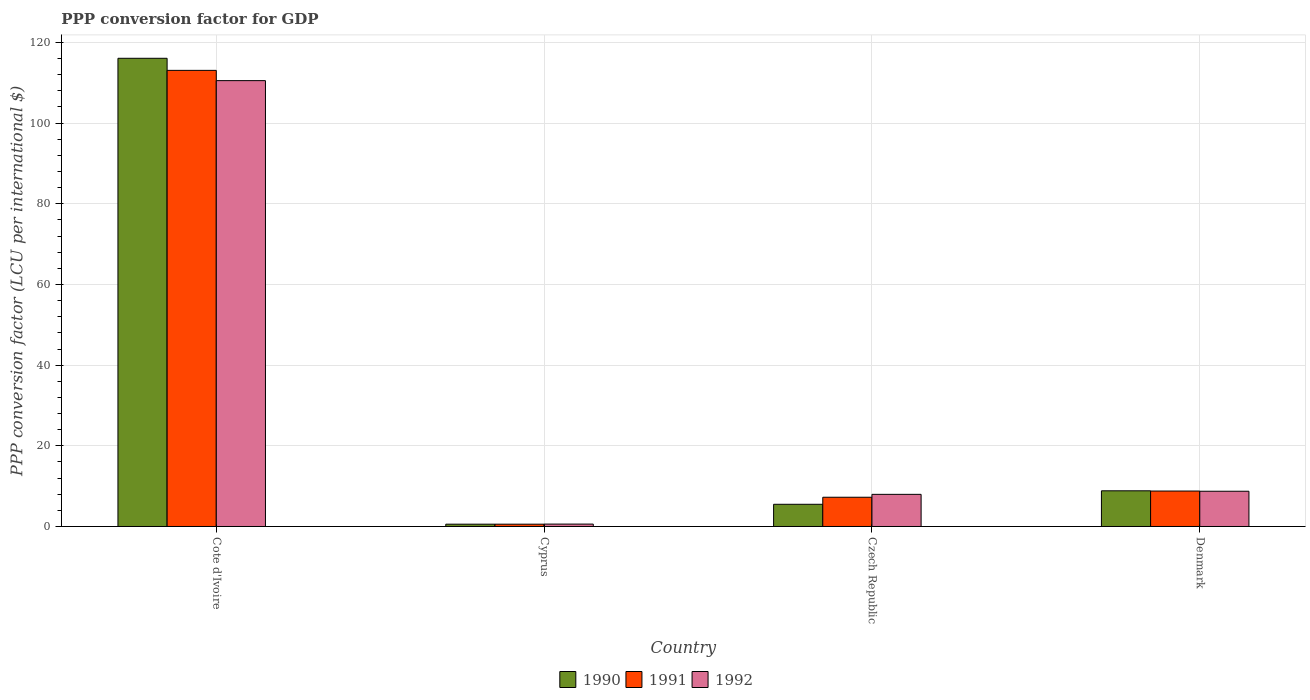How many different coloured bars are there?
Keep it short and to the point. 3. Are the number of bars per tick equal to the number of legend labels?
Your answer should be very brief. Yes. Are the number of bars on each tick of the X-axis equal?
Keep it short and to the point. Yes. What is the label of the 3rd group of bars from the left?
Ensure brevity in your answer.  Czech Republic. What is the PPP conversion factor for GDP in 1990 in Cyprus?
Keep it short and to the point. 0.57. Across all countries, what is the maximum PPP conversion factor for GDP in 1990?
Provide a succinct answer. 116.07. Across all countries, what is the minimum PPP conversion factor for GDP in 1992?
Your answer should be compact. 0.59. In which country was the PPP conversion factor for GDP in 1991 maximum?
Keep it short and to the point. Cote d'Ivoire. In which country was the PPP conversion factor for GDP in 1992 minimum?
Ensure brevity in your answer.  Cyprus. What is the total PPP conversion factor for GDP in 1992 in the graph?
Give a very brief answer. 127.83. What is the difference between the PPP conversion factor for GDP in 1990 in Cyprus and that in Denmark?
Provide a short and direct response. -8.27. What is the difference between the PPP conversion factor for GDP in 1992 in Cyprus and the PPP conversion factor for GDP in 1990 in Cote d'Ivoire?
Your response must be concise. -115.48. What is the average PPP conversion factor for GDP in 1991 per country?
Give a very brief answer. 32.42. What is the difference between the PPP conversion factor for GDP of/in 1990 and PPP conversion factor for GDP of/in 1992 in Denmark?
Ensure brevity in your answer.  0.11. What is the ratio of the PPP conversion factor for GDP in 1992 in Cote d'Ivoire to that in Denmark?
Provide a succinct answer. 12.65. Is the difference between the PPP conversion factor for GDP in 1990 in Cote d'Ivoire and Denmark greater than the difference between the PPP conversion factor for GDP in 1992 in Cote d'Ivoire and Denmark?
Give a very brief answer. Yes. What is the difference between the highest and the second highest PPP conversion factor for GDP in 1992?
Your answer should be compact. -101.79. What is the difference between the highest and the lowest PPP conversion factor for GDP in 1990?
Your answer should be very brief. 115.5. What does the 1st bar from the right in Denmark represents?
Keep it short and to the point. 1992. Is it the case that in every country, the sum of the PPP conversion factor for GDP in 1992 and PPP conversion factor for GDP in 1990 is greater than the PPP conversion factor for GDP in 1991?
Give a very brief answer. Yes. How many bars are there?
Your answer should be compact. 12. Are all the bars in the graph horizontal?
Give a very brief answer. No. Does the graph contain grids?
Provide a succinct answer. Yes. Where does the legend appear in the graph?
Offer a very short reply. Bottom center. How many legend labels are there?
Offer a terse response. 3. How are the legend labels stacked?
Your answer should be very brief. Horizontal. What is the title of the graph?
Provide a short and direct response. PPP conversion factor for GDP. What is the label or title of the Y-axis?
Make the answer very short. PPP conversion factor (LCU per international $). What is the PPP conversion factor (LCU per international $) in 1990 in Cote d'Ivoire?
Give a very brief answer. 116.07. What is the PPP conversion factor (LCU per international $) of 1991 in Cote d'Ivoire?
Provide a succinct answer. 113.08. What is the PPP conversion factor (LCU per international $) of 1992 in Cote d'Ivoire?
Your answer should be very brief. 110.53. What is the PPP conversion factor (LCU per international $) of 1990 in Cyprus?
Your answer should be very brief. 0.57. What is the PPP conversion factor (LCU per international $) in 1991 in Cyprus?
Keep it short and to the point. 0.57. What is the PPP conversion factor (LCU per international $) of 1992 in Cyprus?
Provide a succinct answer. 0.59. What is the PPP conversion factor (LCU per international $) in 1990 in Czech Republic?
Your answer should be very brief. 5.5. What is the PPP conversion factor (LCU per international $) in 1991 in Czech Republic?
Your answer should be very brief. 7.25. What is the PPP conversion factor (LCU per international $) of 1992 in Czech Republic?
Your response must be concise. 7.97. What is the PPP conversion factor (LCU per international $) in 1990 in Denmark?
Make the answer very short. 8.84. What is the PPP conversion factor (LCU per international $) in 1991 in Denmark?
Provide a succinct answer. 8.79. What is the PPP conversion factor (LCU per international $) in 1992 in Denmark?
Your answer should be compact. 8.74. Across all countries, what is the maximum PPP conversion factor (LCU per international $) of 1990?
Keep it short and to the point. 116.07. Across all countries, what is the maximum PPP conversion factor (LCU per international $) of 1991?
Provide a short and direct response. 113.08. Across all countries, what is the maximum PPP conversion factor (LCU per international $) in 1992?
Your answer should be very brief. 110.53. Across all countries, what is the minimum PPP conversion factor (LCU per international $) in 1990?
Provide a short and direct response. 0.57. Across all countries, what is the minimum PPP conversion factor (LCU per international $) in 1991?
Your response must be concise. 0.57. Across all countries, what is the minimum PPP conversion factor (LCU per international $) of 1992?
Provide a short and direct response. 0.59. What is the total PPP conversion factor (LCU per international $) of 1990 in the graph?
Give a very brief answer. 130.99. What is the total PPP conversion factor (LCU per international $) in 1991 in the graph?
Your response must be concise. 129.69. What is the total PPP conversion factor (LCU per international $) in 1992 in the graph?
Give a very brief answer. 127.83. What is the difference between the PPP conversion factor (LCU per international $) in 1990 in Cote d'Ivoire and that in Cyprus?
Offer a very short reply. 115.5. What is the difference between the PPP conversion factor (LCU per international $) in 1991 in Cote d'Ivoire and that in Cyprus?
Offer a very short reply. 112.5. What is the difference between the PPP conversion factor (LCU per international $) in 1992 in Cote d'Ivoire and that in Cyprus?
Your response must be concise. 109.94. What is the difference between the PPP conversion factor (LCU per international $) of 1990 in Cote d'Ivoire and that in Czech Republic?
Provide a short and direct response. 110.57. What is the difference between the PPP conversion factor (LCU per international $) in 1991 in Cote d'Ivoire and that in Czech Republic?
Offer a very short reply. 105.83. What is the difference between the PPP conversion factor (LCU per international $) in 1992 in Cote d'Ivoire and that in Czech Republic?
Provide a short and direct response. 102.56. What is the difference between the PPP conversion factor (LCU per international $) in 1990 in Cote d'Ivoire and that in Denmark?
Give a very brief answer. 107.23. What is the difference between the PPP conversion factor (LCU per international $) in 1991 in Cote d'Ivoire and that in Denmark?
Your response must be concise. 104.29. What is the difference between the PPP conversion factor (LCU per international $) in 1992 in Cote d'Ivoire and that in Denmark?
Give a very brief answer. 101.79. What is the difference between the PPP conversion factor (LCU per international $) in 1990 in Cyprus and that in Czech Republic?
Offer a terse response. -4.93. What is the difference between the PPP conversion factor (LCU per international $) of 1991 in Cyprus and that in Czech Republic?
Give a very brief answer. -6.68. What is the difference between the PPP conversion factor (LCU per international $) of 1992 in Cyprus and that in Czech Republic?
Offer a very short reply. -7.37. What is the difference between the PPP conversion factor (LCU per international $) of 1990 in Cyprus and that in Denmark?
Offer a very short reply. -8.27. What is the difference between the PPP conversion factor (LCU per international $) in 1991 in Cyprus and that in Denmark?
Offer a terse response. -8.22. What is the difference between the PPP conversion factor (LCU per international $) in 1992 in Cyprus and that in Denmark?
Provide a succinct answer. -8.14. What is the difference between the PPP conversion factor (LCU per international $) of 1990 in Czech Republic and that in Denmark?
Provide a succinct answer. -3.34. What is the difference between the PPP conversion factor (LCU per international $) in 1991 in Czech Republic and that in Denmark?
Provide a succinct answer. -1.54. What is the difference between the PPP conversion factor (LCU per international $) in 1992 in Czech Republic and that in Denmark?
Offer a very short reply. -0.77. What is the difference between the PPP conversion factor (LCU per international $) of 1990 in Cote d'Ivoire and the PPP conversion factor (LCU per international $) of 1991 in Cyprus?
Make the answer very short. 115.5. What is the difference between the PPP conversion factor (LCU per international $) of 1990 in Cote d'Ivoire and the PPP conversion factor (LCU per international $) of 1992 in Cyprus?
Your response must be concise. 115.48. What is the difference between the PPP conversion factor (LCU per international $) of 1991 in Cote d'Ivoire and the PPP conversion factor (LCU per international $) of 1992 in Cyprus?
Ensure brevity in your answer.  112.48. What is the difference between the PPP conversion factor (LCU per international $) in 1990 in Cote d'Ivoire and the PPP conversion factor (LCU per international $) in 1991 in Czech Republic?
Your answer should be compact. 108.82. What is the difference between the PPP conversion factor (LCU per international $) in 1990 in Cote d'Ivoire and the PPP conversion factor (LCU per international $) in 1992 in Czech Republic?
Offer a very short reply. 108.11. What is the difference between the PPP conversion factor (LCU per international $) in 1991 in Cote d'Ivoire and the PPP conversion factor (LCU per international $) in 1992 in Czech Republic?
Provide a short and direct response. 105.11. What is the difference between the PPP conversion factor (LCU per international $) of 1990 in Cote d'Ivoire and the PPP conversion factor (LCU per international $) of 1991 in Denmark?
Provide a succinct answer. 107.28. What is the difference between the PPP conversion factor (LCU per international $) in 1990 in Cote d'Ivoire and the PPP conversion factor (LCU per international $) in 1992 in Denmark?
Your response must be concise. 107.33. What is the difference between the PPP conversion factor (LCU per international $) in 1991 in Cote d'Ivoire and the PPP conversion factor (LCU per international $) in 1992 in Denmark?
Your answer should be very brief. 104.34. What is the difference between the PPP conversion factor (LCU per international $) in 1990 in Cyprus and the PPP conversion factor (LCU per international $) in 1991 in Czech Republic?
Offer a very short reply. -6.68. What is the difference between the PPP conversion factor (LCU per international $) in 1990 in Cyprus and the PPP conversion factor (LCU per international $) in 1992 in Czech Republic?
Your response must be concise. -7.4. What is the difference between the PPP conversion factor (LCU per international $) in 1991 in Cyprus and the PPP conversion factor (LCU per international $) in 1992 in Czech Republic?
Offer a terse response. -7.39. What is the difference between the PPP conversion factor (LCU per international $) of 1990 in Cyprus and the PPP conversion factor (LCU per international $) of 1991 in Denmark?
Provide a short and direct response. -8.22. What is the difference between the PPP conversion factor (LCU per international $) of 1990 in Cyprus and the PPP conversion factor (LCU per international $) of 1992 in Denmark?
Give a very brief answer. -8.17. What is the difference between the PPP conversion factor (LCU per international $) of 1991 in Cyprus and the PPP conversion factor (LCU per international $) of 1992 in Denmark?
Provide a short and direct response. -8.16. What is the difference between the PPP conversion factor (LCU per international $) in 1990 in Czech Republic and the PPP conversion factor (LCU per international $) in 1991 in Denmark?
Keep it short and to the point. -3.29. What is the difference between the PPP conversion factor (LCU per international $) of 1990 in Czech Republic and the PPP conversion factor (LCU per international $) of 1992 in Denmark?
Make the answer very short. -3.24. What is the difference between the PPP conversion factor (LCU per international $) in 1991 in Czech Republic and the PPP conversion factor (LCU per international $) in 1992 in Denmark?
Give a very brief answer. -1.49. What is the average PPP conversion factor (LCU per international $) of 1990 per country?
Give a very brief answer. 32.75. What is the average PPP conversion factor (LCU per international $) in 1991 per country?
Your answer should be compact. 32.42. What is the average PPP conversion factor (LCU per international $) of 1992 per country?
Your answer should be very brief. 31.96. What is the difference between the PPP conversion factor (LCU per international $) of 1990 and PPP conversion factor (LCU per international $) of 1991 in Cote d'Ivoire?
Provide a succinct answer. 2.99. What is the difference between the PPP conversion factor (LCU per international $) in 1990 and PPP conversion factor (LCU per international $) in 1992 in Cote d'Ivoire?
Provide a short and direct response. 5.54. What is the difference between the PPP conversion factor (LCU per international $) of 1991 and PPP conversion factor (LCU per international $) of 1992 in Cote d'Ivoire?
Offer a very short reply. 2.55. What is the difference between the PPP conversion factor (LCU per international $) in 1990 and PPP conversion factor (LCU per international $) in 1991 in Cyprus?
Provide a succinct answer. -0. What is the difference between the PPP conversion factor (LCU per international $) in 1990 and PPP conversion factor (LCU per international $) in 1992 in Cyprus?
Make the answer very short. -0.02. What is the difference between the PPP conversion factor (LCU per international $) in 1991 and PPP conversion factor (LCU per international $) in 1992 in Cyprus?
Your answer should be compact. -0.02. What is the difference between the PPP conversion factor (LCU per international $) of 1990 and PPP conversion factor (LCU per international $) of 1991 in Czech Republic?
Offer a very short reply. -1.75. What is the difference between the PPP conversion factor (LCU per international $) of 1990 and PPP conversion factor (LCU per international $) of 1992 in Czech Republic?
Your response must be concise. -2.46. What is the difference between the PPP conversion factor (LCU per international $) of 1991 and PPP conversion factor (LCU per international $) of 1992 in Czech Republic?
Your answer should be very brief. -0.71. What is the difference between the PPP conversion factor (LCU per international $) of 1990 and PPP conversion factor (LCU per international $) of 1991 in Denmark?
Keep it short and to the point. 0.06. What is the difference between the PPP conversion factor (LCU per international $) in 1990 and PPP conversion factor (LCU per international $) in 1992 in Denmark?
Your answer should be very brief. 0.11. What is the difference between the PPP conversion factor (LCU per international $) in 1991 and PPP conversion factor (LCU per international $) in 1992 in Denmark?
Your response must be concise. 0.05. What is the ratio of the PPP conversion factor (LCU per international $) of 1990 in Cote d'Ivoire to that in Cyprus?
Provide a succinct answer. 203.55. What is the ratio of the PPP conversion factor (LCU per international $) of 1991 in Cote d'Ivoire to that in Cyprus?
Keep it short and to the point. 197.23. What is the ratio of the PPP conversion factor (LCU per international $) in 1992 in Cote d'Ivoire to that in Cyprus?
Offer a very short reply. 185.95. What is the ratio of the PPP conversion factor (LCU per international $) of 1990 in Cote d'Ivoire to that in Czech Republic?
Offer a very short reply. 21.1. What is the ratio of the PPP conversion factor (LCU per international $) in 1991 in Cote d'Ivoire to that in Czech Republic?
Keep it short and to the point. 15.59. What is the ratio of the PPP conversion factor (LCU per international $) in 1992 in Cote d'Ivoire to that in Czech Republic?
Your answer should be compact. 13.88. What is the ratio of the PPP conversion factor (LCU per international $) in 1990 in Cote d'Ivoire to that in Denmark?
Offer a very short reply. 13.12. What is the ratio of the PPP conversion factor (LCU per international $) of 1991 in Cote d'Ivoire to that in Denmark?
Provide a succinct answer. 12.87. What is the ratio of the PPP conversion factor (LCU per international $) in 1992 in Cote d'Ivoire to that in Denmark?
Your answer should be compact. 12.65. What is the ratio of the PPP conversion factor (LCU per international $) in 1990 in Cyprus to that in Czech Republic?
Your response must be concise. 0.1. What is the ratio of the PPP conversion factor (LCU per international $) in 1991 in Cyprus to that in Czech Republic?
Offer a terse response. 0.08. What is the ratio of the PPP conversion factor (LCU per international $) of 1992 in Cyprus to that in Czech Republic?
Provide a short and direct response. 0.07. What is the ratio of the PPP conversion factor (LCU per international $) in 1990 in Cyprus to that in Denmark?
Provide a succinct answer. 0.06. What is the ratio of the PPP conversion factor (LCU per international $) in 1991 in Cyprus to that in Denmark?
Ensure brevity in your answer.  0.07. What is the ratio of the PPP conversion factor (LCU per international $) in 1992 in Cyprus to that in Denmark?
Make the answer very short. 0.07. What is the ratio of the PPP conversion factor (LCU per international $) of 1990 in Czech Republic to that in Denmark?
Make the answer very short. 0.62. What is the ratio of the PPP conversion factor (LCU per international $) in 1991 in Czech Republic to that in Denmark?
Offer a very short reply. 0.83. What is the ratio of the PPP conversion factor (LCU per international $) in 1992 in Czech Republic to that in Denmark?
Provide a short and direct response. 0.91. What is the difference between the highest and the second highest PPP conversion factor (LCU per international $) in 1990?
Ensure brevity in your answer.  107.23. What is the difference between the highest and the second highest PPP conversion factor (LCU per international $) of 1991?
Ensure brevity in your answer.  104.29. What is the difference between the highest and the second highest PPP conversion factor (LCU per international $) in 1992?
Give a very brief answer. 101.79. What is the difference between the highest and the lowest PPP conversion factor (LCU per international $) in 1990?
Keep it short and to the point. 115.5. What is the difference between the highest and the lowest PPP conversion factor (LCU per international $) in 1991?
Your answer should be compact. 112.5. What is the difference between the highest and the lowest PPP conversion factor (LCU per international $) of 1992?
Keep it short and to the point. 109.94. 